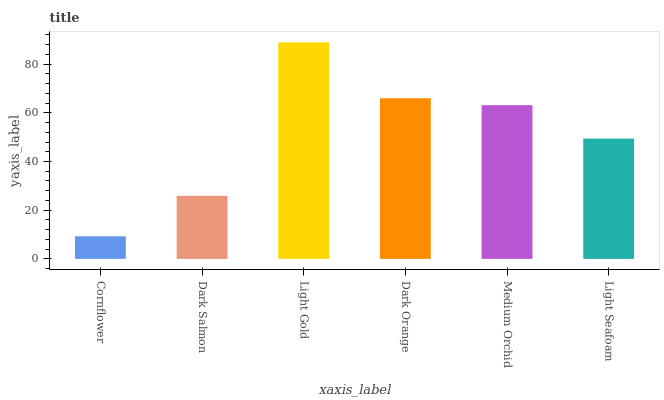Is Cornflower the minimum?
Answer yes or no. Yes. Is Light Gold the maximum?
Answer yes or no. Yes. Is Dark Salmon the minimum?
Answer yes or no. No. Is Dark Salmon the maximum?
Answer yes or no. No. Is Dark Salmon greater than Cornflower?
Answer yes or no. Yes. Is Cornflower less than Dark Salmon?
Answer yes or no. Yes. Is Cornflower greater than Dark Salmon?
Answer yes or no. No. Is Dark Salmon less than Cornflower?
Answer yes or no. No. Is Medium Orchid the high median?
Answer yes or no. Yes. Is Light Seafoam the low median?
Answer yes or no. Yes. Is Dark Orange the high median?
Answer yes or no. No. Is Cornflower the low median?
Answer yes or no. No. 